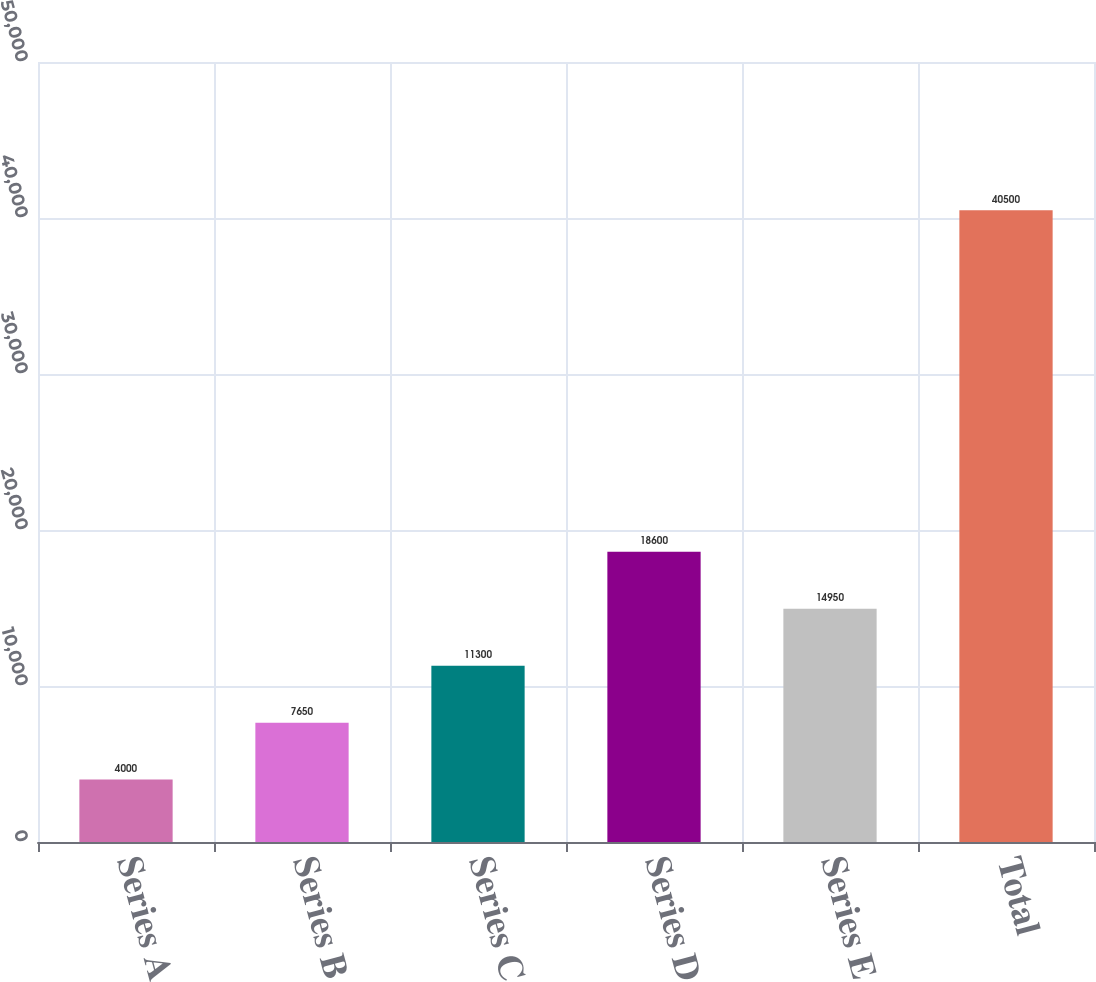<chart> <loc_0><loc_0><loc_500><loc_500><bar_chart><fcel>Series A<fcel>Series B<fcel>Series C<fcel>Series D<fcel>Series E<fcel>Total<nl><fcel>4000<fcel>7650<fcel>11300<fcel>18600<fcel>14950<fcel>40500<nl></chart> 